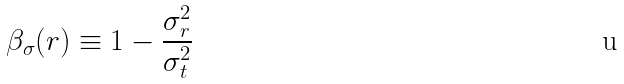Convert formula to latex. <formula><loc_0><loc_0><loc_500><loc_500>\beta _ { \sigma } ( r ) \equiv 1 - \frac { \sigma _ { r } ^ { 2 } } { \sigma _ { t } ^ { 2 } }</formula> 